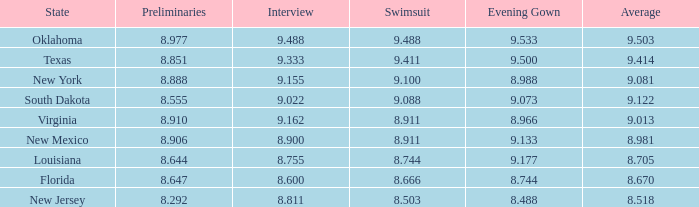 what's the evening gown where preliminaries is 8.977 9.533. 